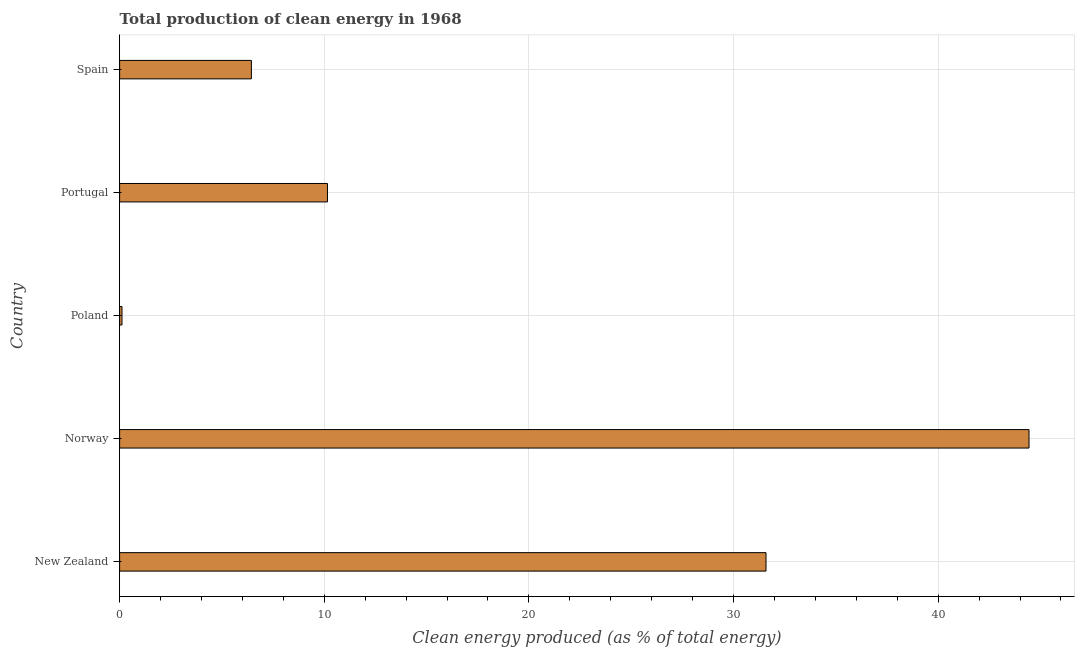What is the title of the graph?
Your answer should be compact. Total production of clean energy in 1968. What is the label or title of the X-axis?
Your response must be concise. Clean energy produced (as % of total energy). What is the production of clean energy in New Zealand?
Your response must be concise. 31.59. Across all countries, what is the maximum production of clean energy?
Make the answer very short. 44.44. Across all countries, what is the minimum production of clean energy?
Keep it short and to the point. 0.12. In which country was the production of clean energy maximum?
Keep it short and to the point. Norway. What is the sum of the production of clean energy?
Your answer should be compact. 92.74. What is the difference between the production of clean energy in Norway and Spain?
Make the answer very short. 38. What is the average production of clean energy per country?
Give a very brief answer. 18.55. What is the median production of clean energy?
Keep it short and to the point. 10.16. In how many countries, is the production of clean energy greater than 34 %?
Provide a succinct answer. 1. What is the ratio of the production of clean energy in New Zealand to that in Norway?
Ensure brevity in your answer.  0.71. Is the production of clean energy in Norway less than that in Poland?
Offer a terse response. No. Is the difference between the production of clean energy in Poland and Portugal greater than the difference between any two countries?
Ensure brevity in your answer.  No. What is the difference between the highest and the second highest production of clean energy?
Your answer should be compact. 12.85. What is the difference between the highest and the lowest production of clean energy?
Your answer should be compact. 44.32. How many bars are there?
Provide a succinct answer. 5. Are all the bars in the graph horizontal?
Give a very brief answer. Yes. What is the difference between two consecutive major ticks on the X-axis?
Provide a short and direct response. 10. Are the values on the major ticks of X-axis written in scientific E-notation?
Keep it short and to the point. No. What is the Clean energy produced (as % of total energy) of New Zealand?
Provide a succinct answer. 31.59. What is the Clean energy produced (as % of total energy) of Norway?
Make the answer very short. 44.44. What is the Clean energy produced (as % of total energy) of Poland?
Your answer should be compact. 0.12. What is the Clean energy produced (as % of total energy) in Portugal?
Your response must be concise. 10.16. What is the Clean energy produced (as % of total energy) of Spain?
Keep it short and to the point. 6.44. What is the difference between the Clean energy produced (as % of total energy) in New Zealand and Norway?
Provide a succinct answer. -12.85. What is the difference between the Clean energy produced (as % of total energy) in New Zealand and Poland?
Offer a terse response. 31.47. What is the difference between the Clean energy produced (as % of total energy) in New Zealand and Portugal?
Your response must be concise. 21.43. What is the difference between the Clean energy produced (as % of total energy) in New Zealand and Spain?
Provide a succinct answer. 25.15. What is the difference between the Clean energy produced (as % of total energy) in Norway and Poland?
Make the answer very short. 44.32. What is the difference between the Clean energy produced (as % of total energy) in Norway and Portugal?
Your response must be concise. 34.28. What is the difference between the Clean energy produced (as % of total energy) in Norway and Spain?
Provide a short and direct response. 38. What is the difference between the Clean energy produced (as % of total energy) in Poland and Portugal?
Ensure brevity in your answer.  -10.04. What is the difference between the Clean energy produced (as % of total energy) in Poland and Spain?
Your answer should be compact. -6.32. What is the difference between the Clean energy produced (as % of total energy) in Portugal and Spain?
Ensure brevity in your answer.  3.72. What is the ratio of the Clean energy produced (as % of total energy) in New Zealand to that in Norway?
Provide a short and direct response. 0.71. What is the ratio of the Clean energy produced (as % of total energy) in New Zealand to that in Poland?
Make the answer very short. 270.3. What is the ratio of the Clean energy produced (as % of total energy) in New Zealand to that in Portugal?
Your answer should be very brief. 3.11. What is the ratio of the Clean energy produced (as % of total energy) in New Zealand to that in Spain?
Offer a very short reply. 4.91. What is the ratio of the Clean energy produced (as % of total energy) in Norway to that in Poland?
Offer a terse response. 380.28. What is the ratio of the Clean energy produced (as % of total energy) in Norway to that in Portugal?
Keep it short and to the point. 4.38. What is the ratio of the Clean energy produced (as % of total energy) in Norway to that in Spain?
Your response must be concise. 6.9. What is the ratio of the Clean energy produced (as % of total energy) in Poland to that in Portugal?
Offer a very short reply. 0.01. What is the ratio of the Clean energy produced (as % of total energy) in Poland to that in Spain?
Offer a very short reply. 0.02. What is the ratio of the Clean energy produced (as % of total energy) in Portugal to that in Spain?
Your answer should be very brief. 1.58. 